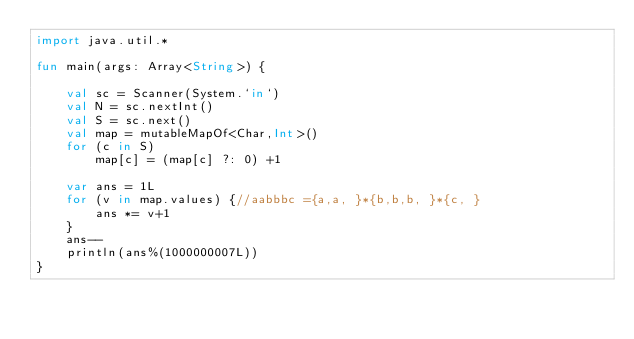Convert code to text. <code><loc_0><loc_0><loc_500><loc_500><_Kotlin_>import java.util.*

fun main(args: Array<String>) {

    val sc = Scanner(System.`in`)
    val N = sc.nextInt()
    val S = sc.next()
    val map = mutableMapOf<Char,Int>()
    for (c in S)
        map[c] = (map[c] ?: 0) +1
    
    var ans = 1L
    for (v in map.values) {//aabbbc ={a,a, }*{b,b,b, }*{c, }
        ans *= v+1
    }
    ans--
    println(ans%(1000000007L))
}</code> 